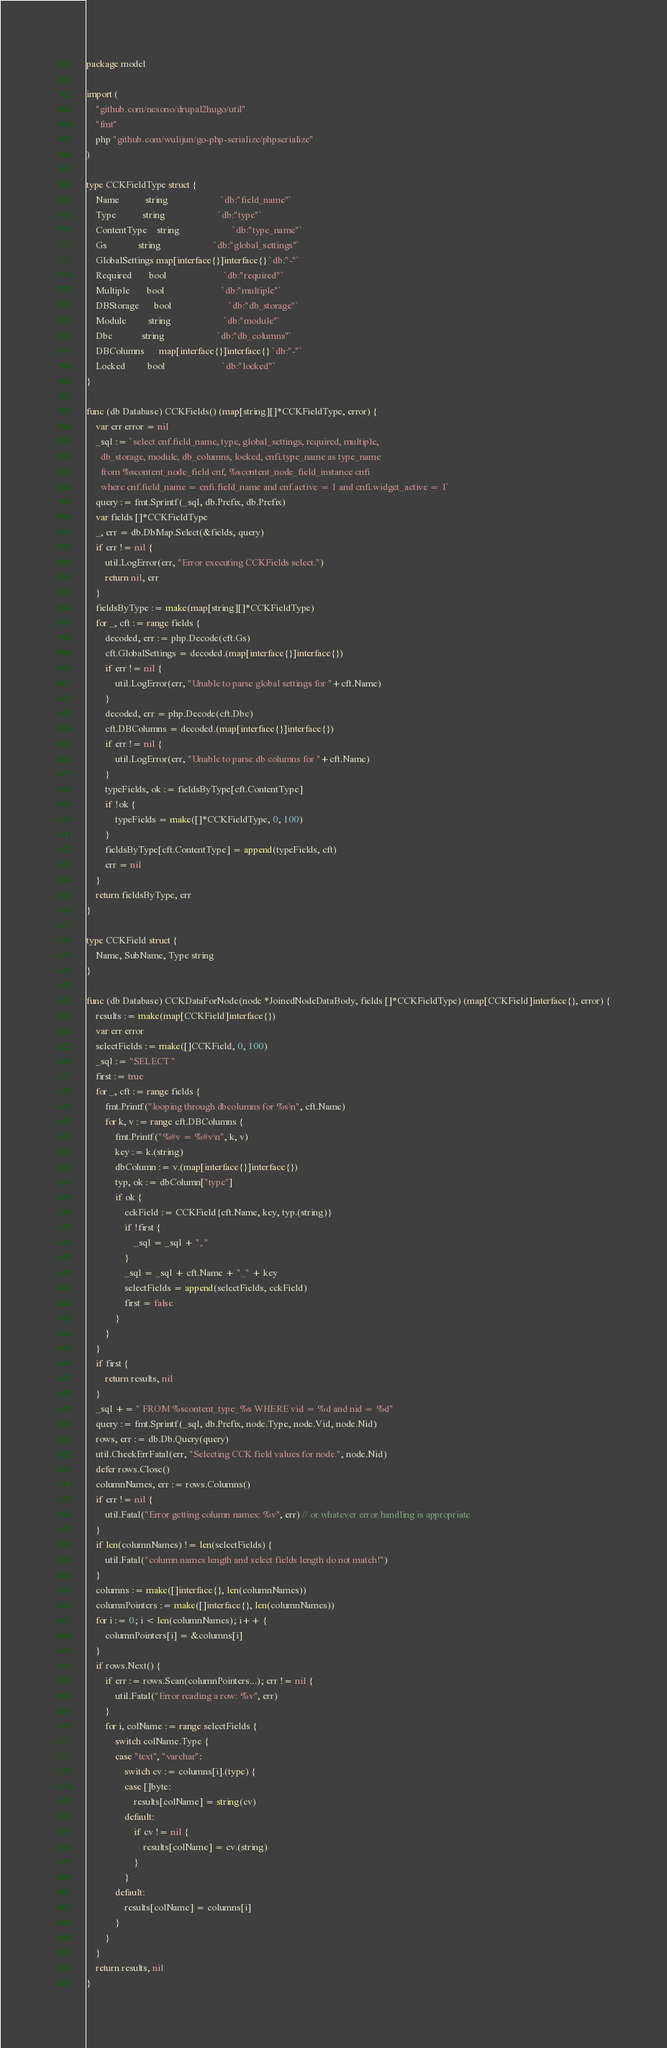<code> <loc_0><loc_0><loc_500><loc_500><_Go_>package model

import (
	"github.com/nesono/drupal2hugo/util"
	"fmt"
	php "github.com/wulijun/go-php-serialize/phpserialize"
)

type CCKFieldType struct {
	Name           string                      `db:"field_name"`
	Type           string                      `db:"type"`
	ContentType    string                      `db:"type_name"`
	Gs             string                      `db:"global_settings"`
	GlobalSettings map[interface{}]interface{} `db:"-"`
	Required       bool                        `db:"required"`
	Multiple       bool                        `db:"multiple"`
	DBStorage      bool                        `db:"db_storage"`
	Module         string                      `db:"module"`
	Dbc            string                      `db:"db_columns"`
	DBColumns      map[interface{}]interface{} `db:"-"`
	Locked         bool                        `db:"locked"`
}

func (db Database) CCKFields() (map[string][]*CCKFieldType, error) {
	var err error = nil
	_sql := `select cnf.field_name, type, global_settings, required, multiple, 
	  db_storage, module, db_columns, locked, cnfi.type_name as type_name
	  from %scontent_node_field cnf, %scontent_node_field_instance cnfi 
	  where cnf.field_name = cnfi.field_name and cnf.active = 1 and cnfi.widget_active = 1`
	query := fmt.Sprintf(_sql, db.Prefix, db.Prefix)
	var fields []*CCKFieldType
	_, err = db.DbMap.Select(&fields, query)
	if err != nil {
		util.LogError(err, "Error executing CCKFields select.")
		return nil, err
	}
	fieldsByType := make(map[string][]*CCKFieldType)
	for _, cft := range fields {
		decoded, err := php.Decode(cft.Gs)
		cft.GlobalSettings = decoded.(map[interface{}]interface{})
		if err != nil {
			util.LogError(err, "Unable to parse global settings for "+cft.Name)
		}
		decoded, err = php.Decode(cft.Dbc)
		cft.DBColumns = decoded.(map[interface{}]interface{})
		if err != nil {
			util.LogError(err, "Unable to parse db columns for "+cft.Name)
		}
		typeFields, ok := fieldsByType[cft.ContentType]
		if !ok {
			typeFields = make([]*CCKFieldType, 0, 100)
		}
		fieldsByType[cft.ContentType] = append(typeFields, cft)
		err = nil
	}
	return fieldsByType, err
}

type CCKField struct {
	Name, SubName, Type string
}

func (db Database) CCKDataForNode(node *JoinedNodeDataBody, fields []*CCKFieldType) (map[CCKField]interface{}, error) {
	results := make(map[CCKField]interface{})
	var err error
	selectFields := make([]CCKField, 0, 100)
	_sql := "SELECT "
	first := true
	for _, cft := range fields {
		fmt.Printf("looping through dbcolumns for %s\n", cft.Name)
		for k, v := range cft.DBColumns {
			fmt.Printf("%#v = %#v\n", k, v)
			key := k.(string)
			dbColumn := v.(map[interface{}]interface{})
			typ, ok := dbColumn["type"]
			if ok {
				cckField := CCKField{cft.Name, key, typ.(string)}
				if !first {
					_sql = _sql + ", "
				}
				_sql = _sql + cft.Name + "_" + key
				selectFields = append(selectFields, cckField)
				first = false
			}
		}
	}
	if first {
		return results, nil
	}
	_sql += " FROM %scontent_type_%s WHERE vid = %d and nid = %d"
	query := fmt.Sprintf(_sql, db.Prefix, node.Type, node.Vid, node.Nid)
	rows, err := db.Db.Query(query)
	util.CheckErrFatal(err, "Selecting CCK field values for node.", node.Nid)
	defer rows.Close()
	columnNames, err := rows.Columns()
	if err != nil {
		util.Fatal("Error getting column names: %v", err) // or whatever error handling is appropriate
	}
	if len(columnNames) != len(selectFields) {
		util.Fatal("column names length and select fields length do not match!")
	}
	columns := make([]interface{}, len(columnNames))
	columnPointers := make([]interface{}, len(columnNames))
	for i := 0; i < len(columnNames); i++ {
		columnPointers[i] = &columns[i]
	}
	if rows.Next() {
		if err := rows.Scan(columnPointers...); err != nil {
			util.Fatal("Error reading a row: %v", err)
		}
		for i, colName := range selectFields {
			switch colName.Type {
			case "text", "varchar":
				switch cv := columns[i].(type) {
				case []byte:
					results[colName] = string(cv)
				default:
					if cv != nil {
						results[colName] = cv.(string)
					}
				}
			default:
				results[colName] = columns[i]
			}
		}
	}
	return results, nil
}
</code> 